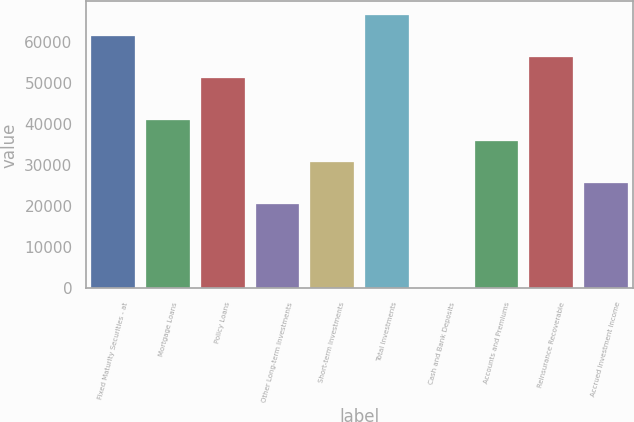Convert chart to OTSL. <chart><loc_0><loc_0><loc_500><loc_500><bar_chart><fcel>Fixed Maturity Securities - at<fcel>Mortgage Loans<fcel>Policy Loans<fcel>Other Long-term Investments<fcel>Short-term Investments<fcel>Total Investments<fcel>Cash and Bank Deposits<fcel>Accounts and Premiums<fcel>Reinsurance Recoverable<fcel>Accrued Investment Income<nl><fcel>61337<fcel>40924.8<fcel>51130.9<fcel>20512.6<fcel>30718.7<fcel>66440.1<fcel>100.4<fcel>35821.8<fcel>56233.9<fcel>25615.7<nl></chart> 